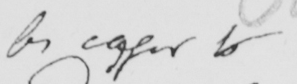Can you tell me what this handwritten text says? be eager to 